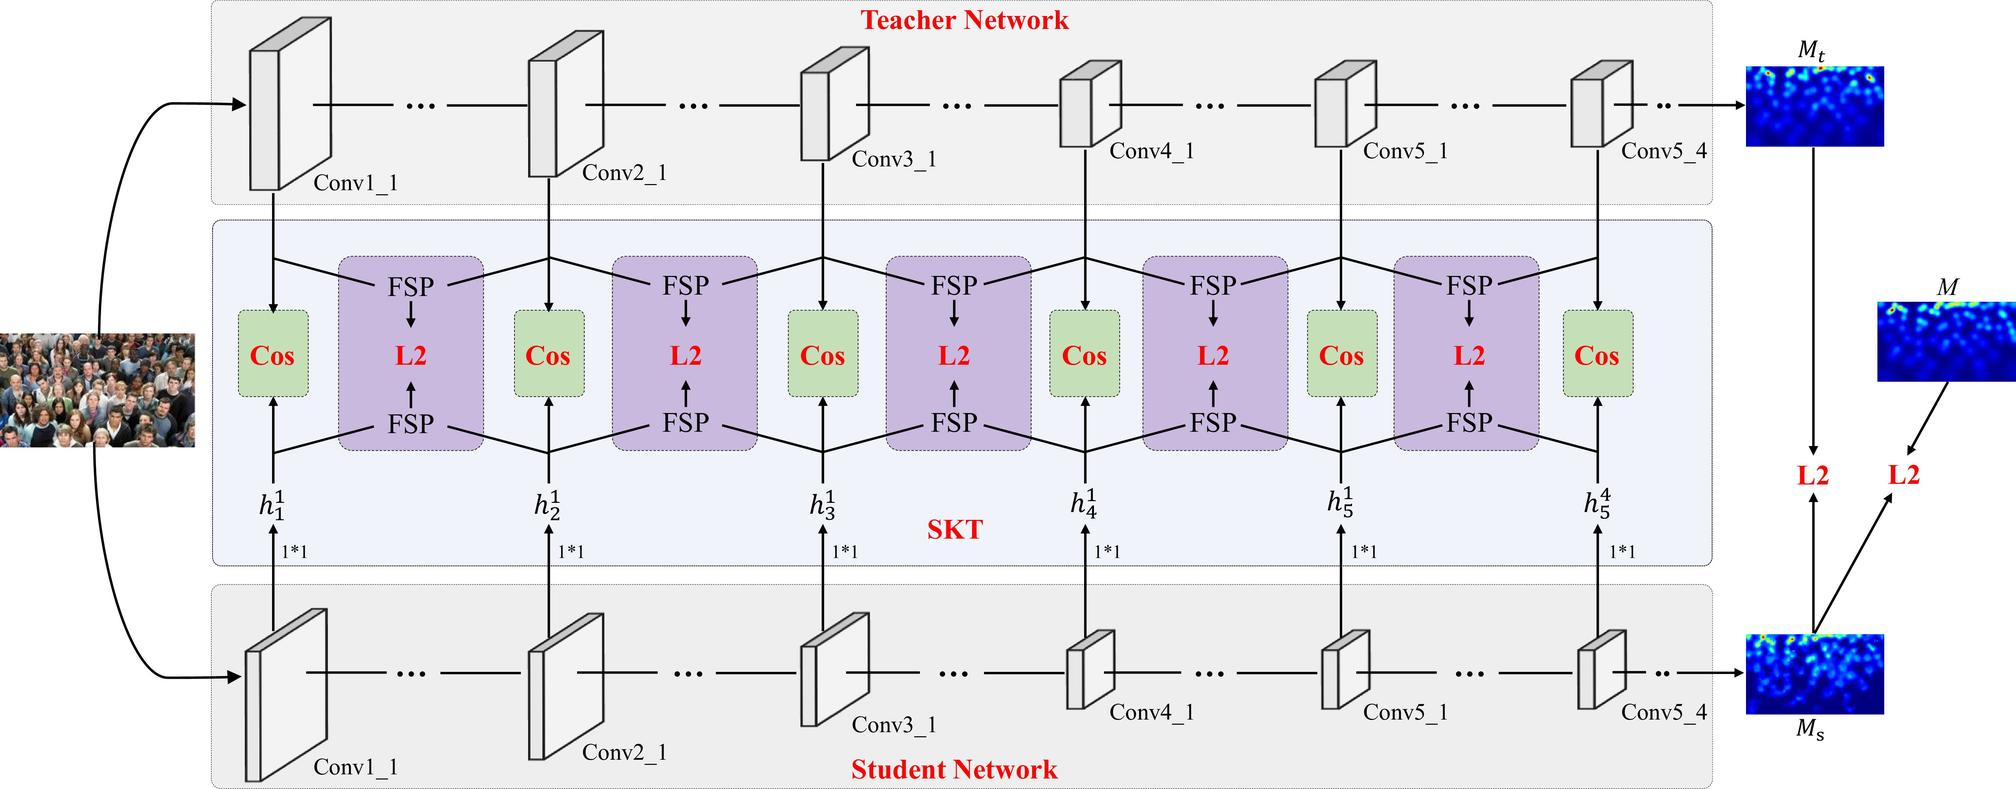In the diagram, what does 'FSP' stand for? A. Full Spectrum Processing B. Feature Space Preservation C. Feature Similarity Profile D. Focused Signal Processing 'FSP' likely stands for Feature Similarity Profile, as it is a common term in neural network training that refers to a method of comparing feature maps to ensure that a student network learns similar features to a teacher network. This is supported by the context of the diagram, which shows a teacher-student network setup commonly used in knowledge distillation, where ensuring feature similarity is crucial. Therefore, the correct answer is C. 